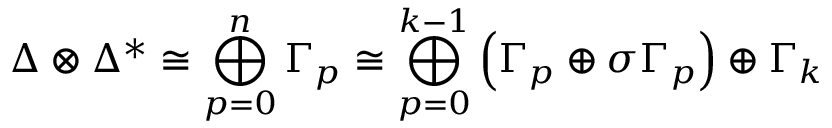Convert formula to latex. <formula><loc_0><loc_0><loc_500><loc_500>\Delta \otimes \Delta ^ { * } \cong \bigoplus _ { p = 0 } ^ { n } \Gamma _ { p } \cong \bigoplus _ { p = 0 } ^ { k - 1 } \left ( \Gamma _ { p } \oplus \sigma \Gamma _ { p } \right ) \oplus \Gamma _ { k }</formula> 